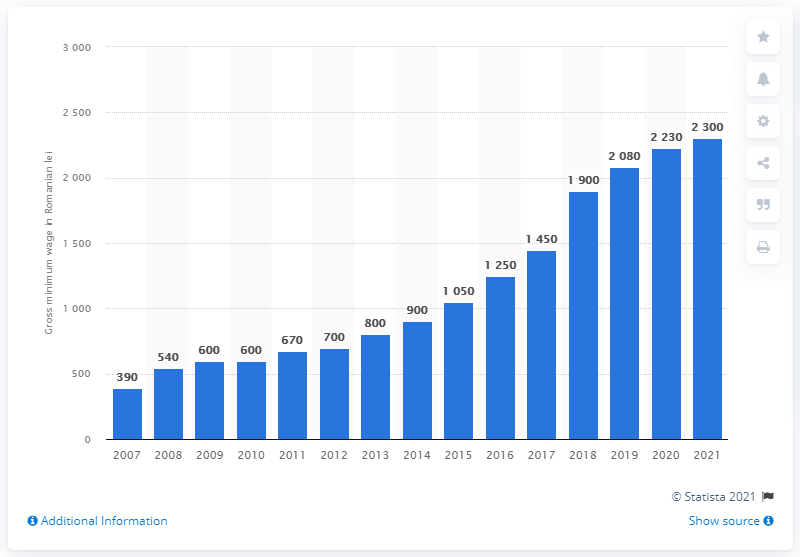Mention a couple of crucial points in this snapshot. The gross minimum wage in Romania increased in the year 2007. 